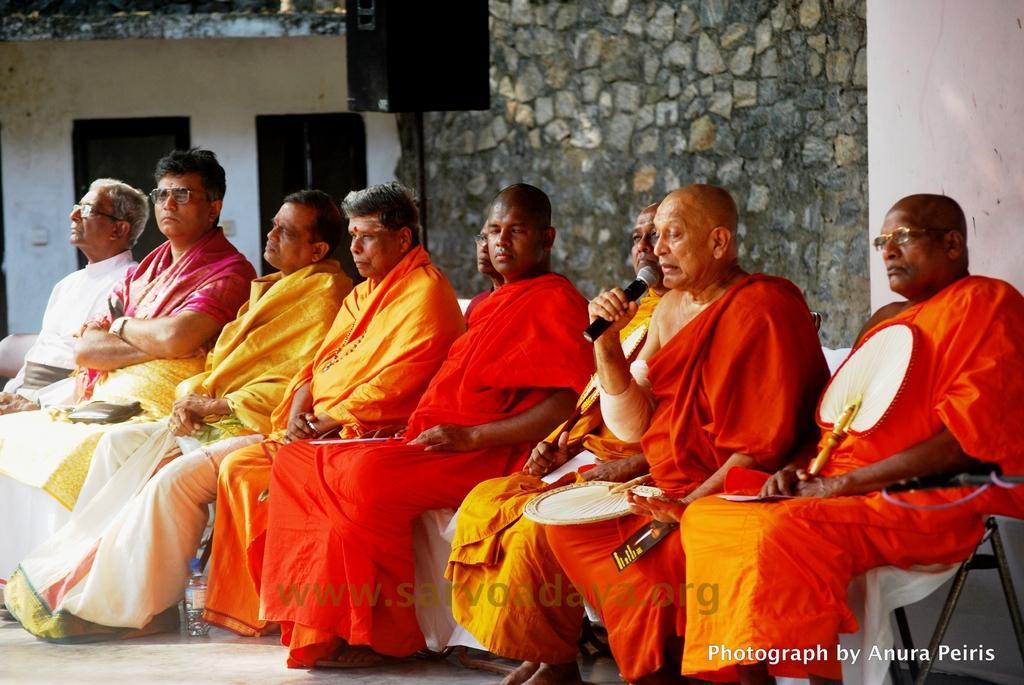How would you summarize this image in a sentence or two? In this image we can see a few people sitting on the chairs, we can see a house, windows, a wall, a person is holding a mic, and talking, there are two hand fans, also we can see a speaker on the stand, and a bottle. 